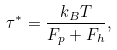Convert formula to latex. <formula><loc_0><loc_0><loc_500><loc_500>\tau ^ { * } = \frac { k _ { B } T } { F _ { p } + F _ { h } } ,</formula> 